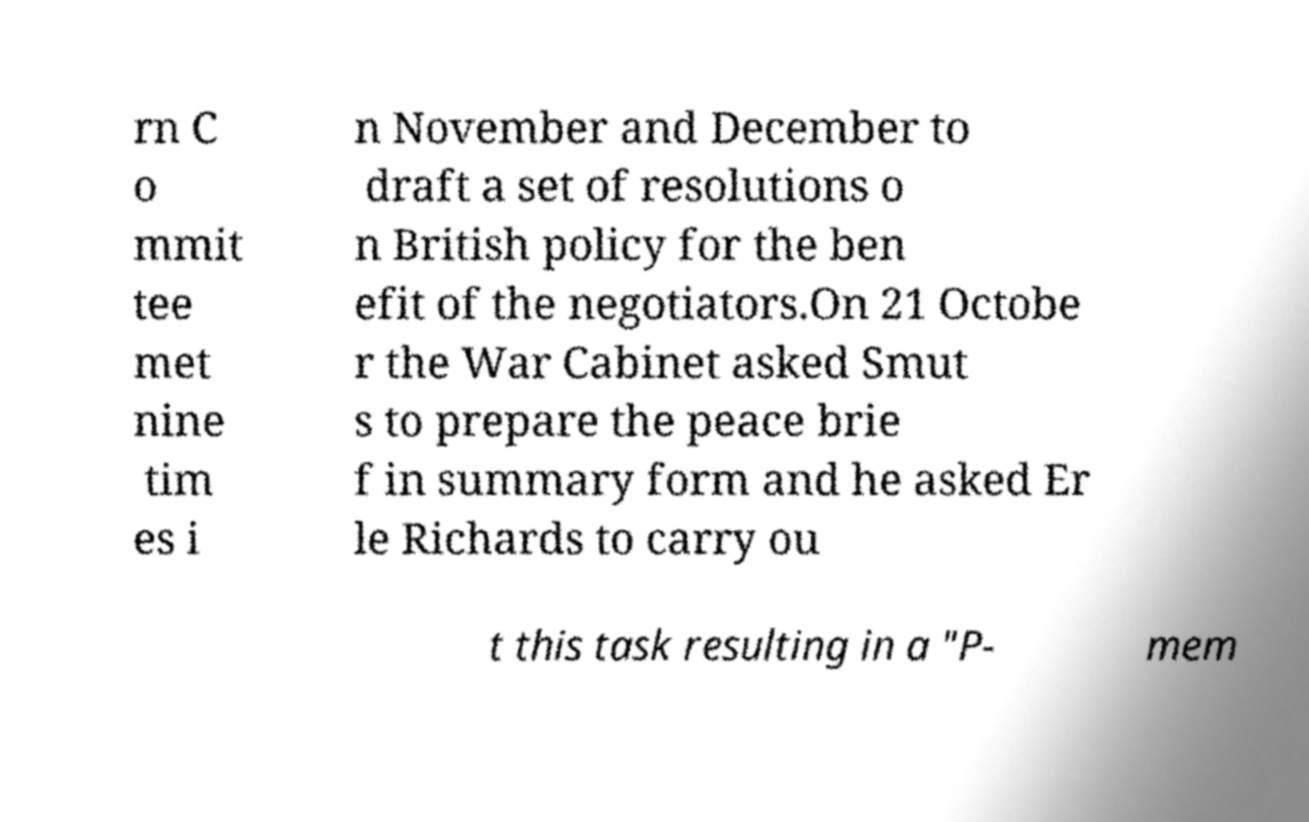For documentation purposes, I need the text within this image transcribed. Could you provide that? rn C o mmit tee met nine tim es i n November and December to draft a set of resolutions o n British policy for the ben efit of the negotiators.On 21 Octobe r the War Cabinet asked Smut s to prepare the peace brie f in summary form and he asked Er le Richards to carry ou t this task resulting in a "P- mem 